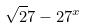Convert formula to latex. <formula><loc_0><loc_0><loc_500><loc_500>\sqrt { 2 } 7 - 2 7 ^ { x }</formula> 